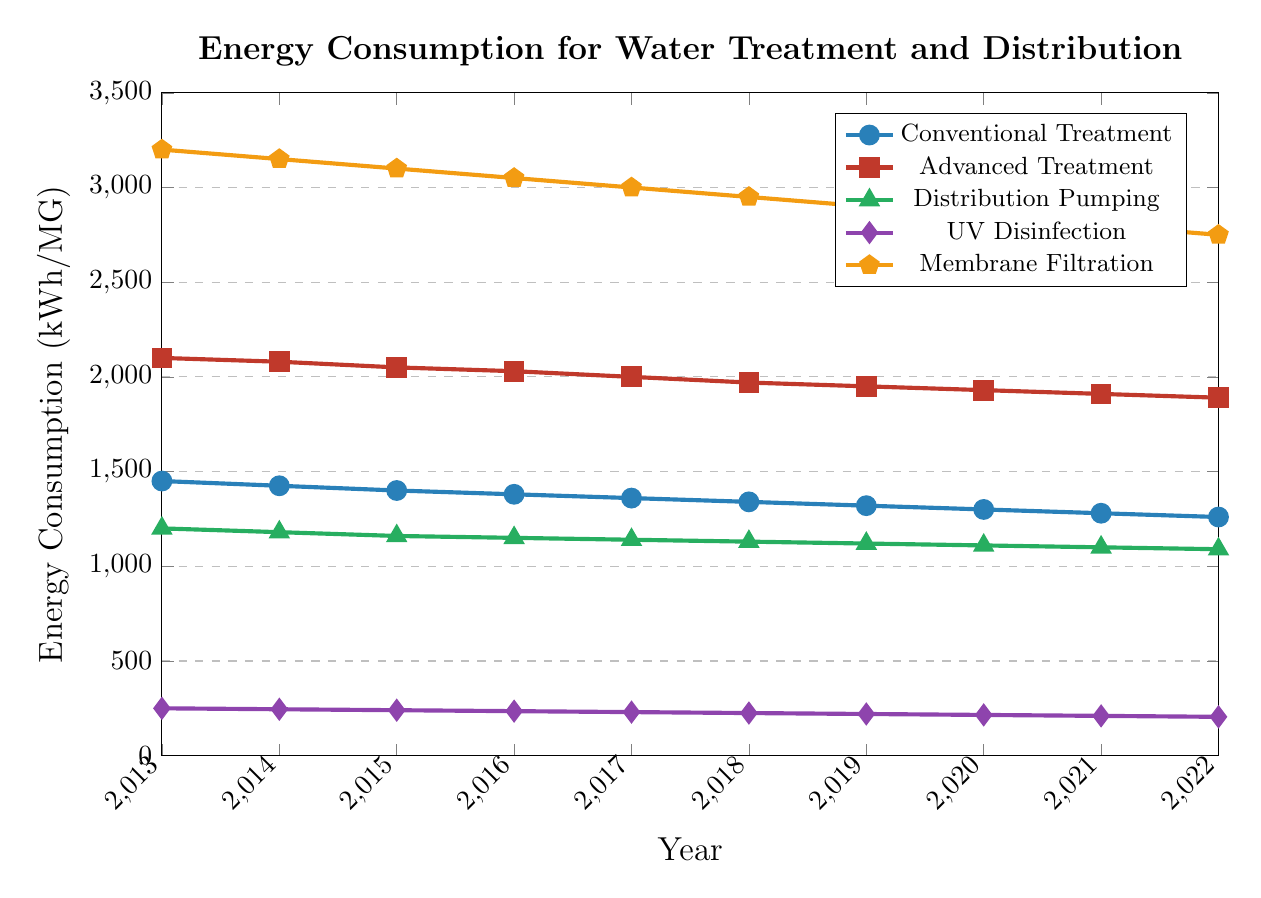What's the trend for energy consumption in Conventional Treatment from 2013 to 2022? The energy consumption for Conventional Treatment steadily decreases each year. By looking at the line representing Conventional Treatment, you can observe a downward slope from 1450 kWh/MG in 2013 to 1260 kWh/MG in 2022.
Answer: Steady decrease Which process had the highest energy consumption in 2022? By examining the vertical positions of the lines at the year 2022, Membrane Filtration at 2750 kWh/MG is the highest.
Answer: Membrane Filtration How much did energy consumption for Membrane Filtration decrease from 2013 to 2022? Calculate the difference between the values of Membrane Filtration in 2013 and 2022: 3200 kWh/MG - 2750 kWh/MG.
Answer: 450 kWh/MG Which water treatment process showed the least amount of change over the years? By comparing the slopes of all the lines, UV Disinfection has the smallest slope, moving from 250 kWh/MG in 2013 to 205 kWh/MG in 2022.
Answer: UV Disinfection In which year did Advanced Treatment consume 2000 kWh/MG? Locate the point on the Advanced Treatment line that intersects with 2000 kWh/MG on the y-axis. This point is in the year 2017.
Answer: 2017 What is the combined energy consumption of Conventional and Advanced Treatment in 2016? Add the energy consumption values for Conventional Treatment (1380 kWh/MG) and Advanced Treatment (2030 kWh/MG) for the year 2016.
Answer: 3410 kWh/MG How does the energy consumption of Distribution Pumping in 2022 compare to UV Disinfection in 2017? Compare the values for Distribution Pumping in 2022 (1090 kWh/MG) and UV Disinfection in 2017 (230 kWh/MG).
Answer: 1090 kWh/MG is much higher than 230 kWh/MG Which process had the lowest energy consumption in 2013? Identify the lowest point among the processes for the year 2013. UV Disinfection has the lowest value at 250 kWh/MG.
Answer: UV Disinfection What's the average decrease in energy consumption per year for Membrane Filtration from 2013 to 2018? Calculate the total decrease from 2013 to 2018 (3200 kWh/MG - 2950 kWh/MG = 250 kWh/MG) and divide by the number of years: 250 kWh/MG / 5 years.
Answer: 50 kWh/MG per year Compare the rate of decrease in energy consumption between Conventional Treatment and Distribution Pumping over the decade. 1. Find the decrease for each: 
   - Conventional Treatment: 1450 kWh/MG in 2013 to 1260 kWh/MG in 2022 (1450 - 1260 = 190 kWh/MG)
   - Distribution Pumping: 1200 kWh/MG in 2013 to 1090 kWh/MG in 2022 (1200 - 1090 = 110 kWh/MG)
2. Determine that Conventional Treatment has a greater decrease (190 kWh/MG vs. 110 kWh/MG).
Answer: Conventional Treatment has a greater rate of decrease 